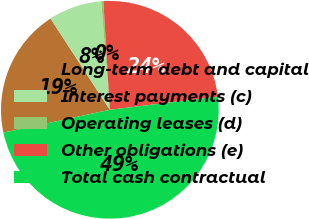Convert chart. <chart><loc_0><loc_0><loc_500><loc_500><pie_chart><fcel>Long-term debt and capital<fcel>Interest payments (c)<fcel>Operating leases (d)<fcel>Other obligations (e)<fcel>Total cash contractual<nl><fcel>19.2%<fcel>7.9%<fcel>0.32%<fcel>24.02%<fcel>48.57%<nl></chart> 